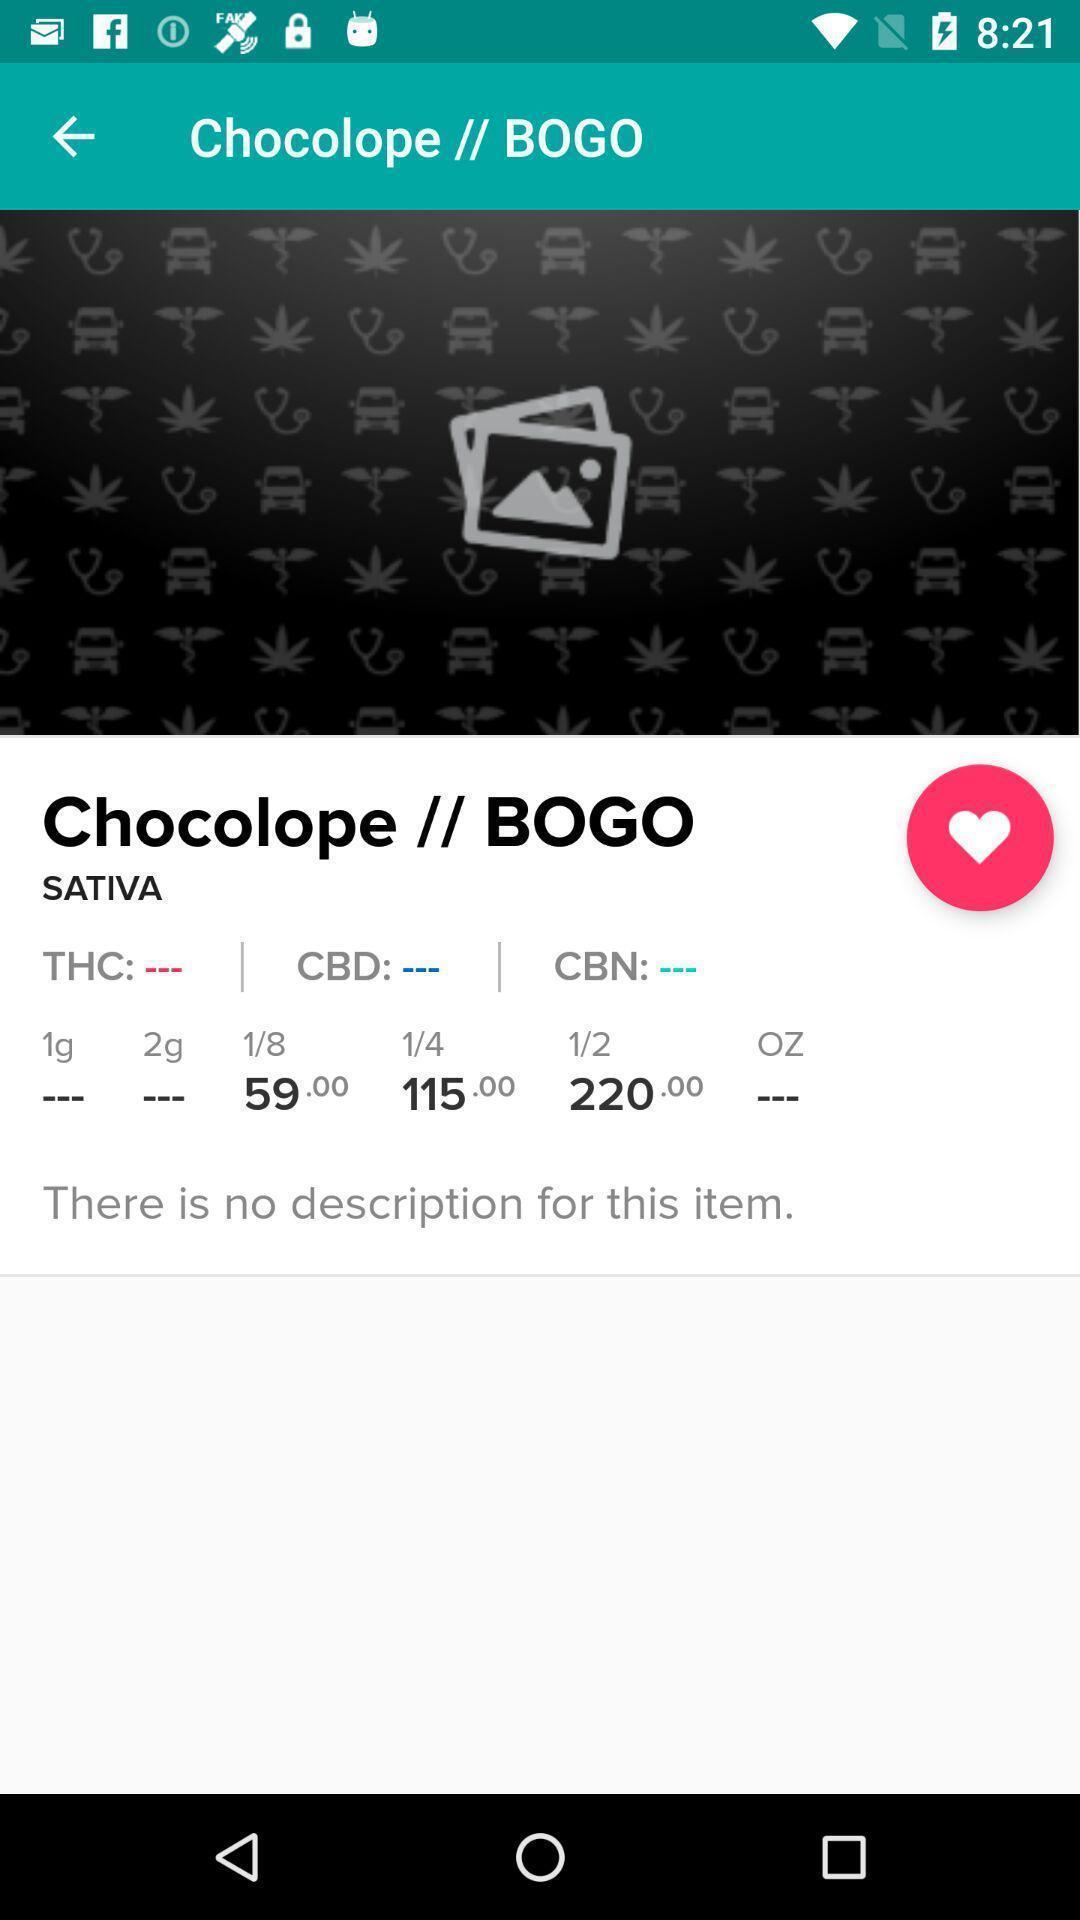Please provide a description for this image. Page displaying the description of the item. 